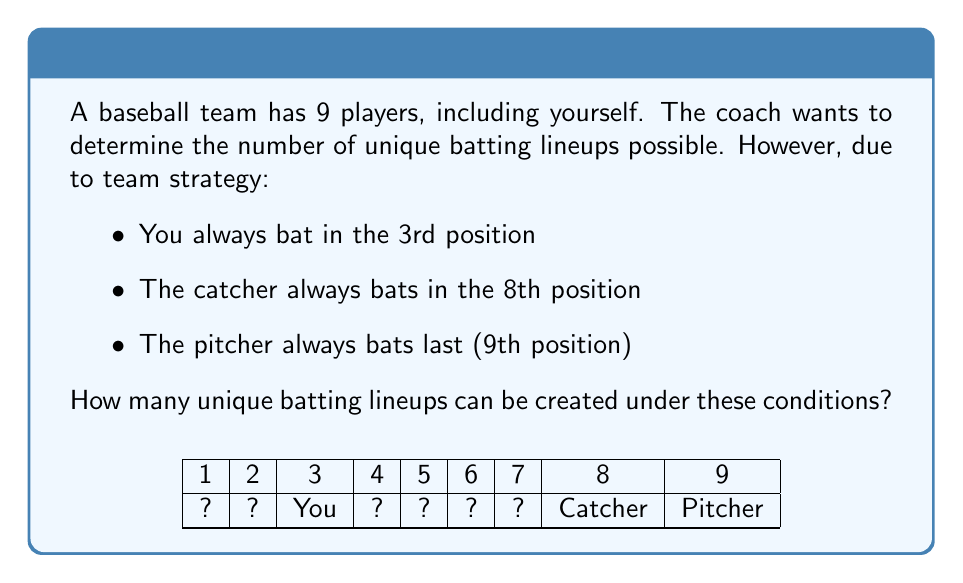Can you solve this math problem? Let's approach this step-by-step using permutation groups:

1) We start with 9 players, but 3 positions are fixed:
   - You in 3rd
   - Catcher in 8th
   - Pitcher in 9th

2) This leaves 6 players to be arranged in the remaining 6 positions (1st, 2nd, 4th, 5th, 6th, and 7th).

3) The number of ways to arrange 6 players in 6 positions is a straightforward permutation:

   $$P(6,6) = 6! = 6 \times 5 \times 4 \times 3 \times 2 \times 1 = 720$$

4) This can be thought of as the order of a permutation group on 6 elements, which is always 6!.

5) In group theory terms, we're looking at the symmetric group $S_6$, which has order 720.

6) Each permutation in this group represents a unique lineup for the 6 variable positions.

7) The fixed positions (3rd, 8th, and 9th) don't affect the number of permutations, as they remain constant across all lineups.

Therefore, there are 720 unique batting lineups possible under the given conditions.
Answer: 720 